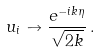Convert formula to latex. <formula><loc_0><loc_0><loc_500><loc_500>u _ { i } \to \frac { e ^ { - i k \eta } } { \sqrt { 2 k } } \, .</formula> 